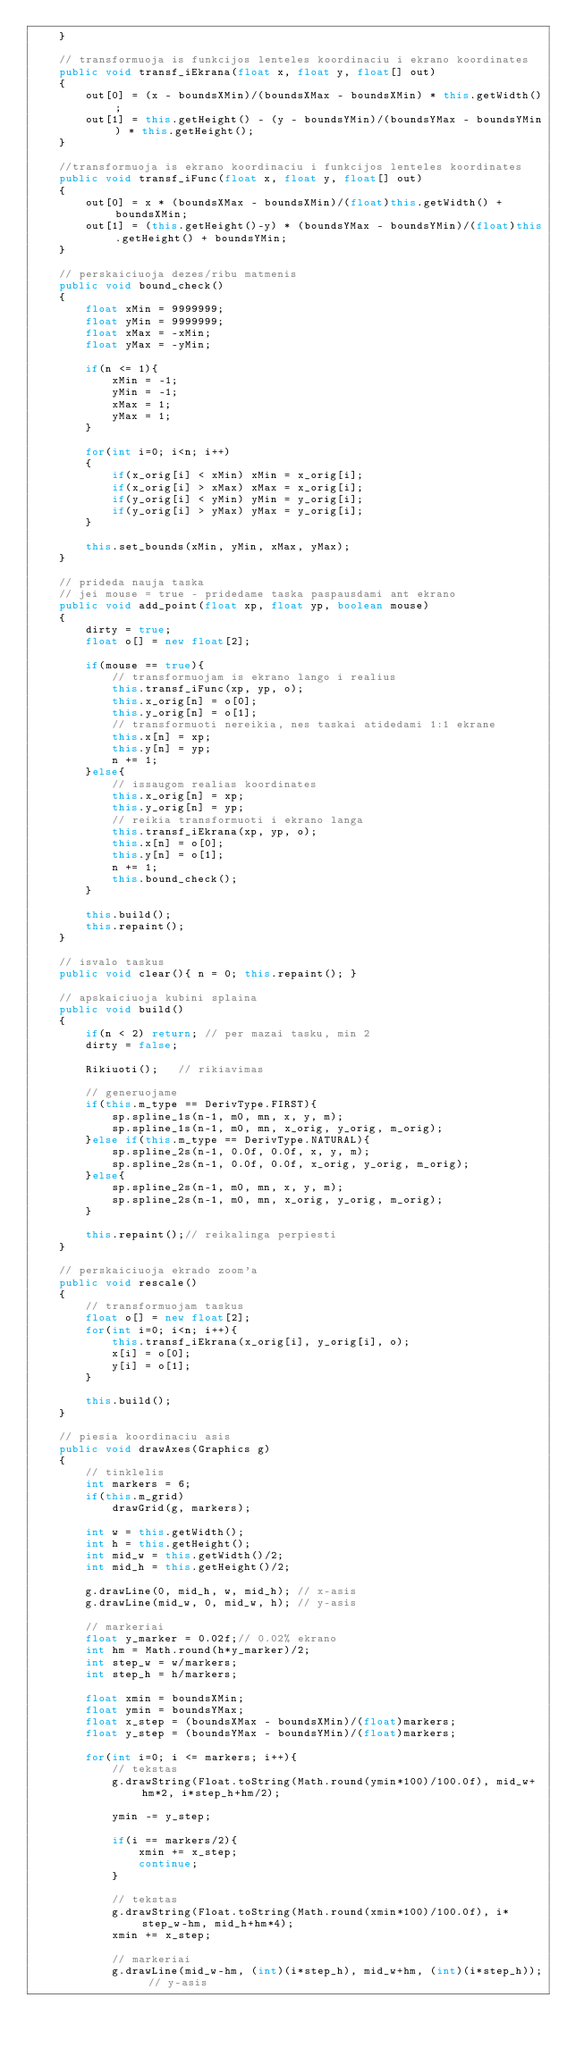Convert code to text. <code><loc_0><loc_0><loc_500><loc_500><_Java_>    }

    // transformuoja is funkcijos lenteles koordinaciu i ekrano koordinates
    public void transf_iEkrana(float x, float y, float[] out)
    {
        out[0] = (x - boundsXMin)/(boundsXMax - boundsXMin) * this.getWidth();
        out[1] = this.getHeight() - (y - boundsYMin)/(boundsYMax - boundsYMin) * this.getHeight();
    }

    //transformuoja is ekrano koordinaciu i funkcijos lenteles koordinates
    public void transf_iFunc(float x, float y, float[] out)
    {
        out[0] = x * (boundsXMax - boundsXMin)/(float)this.getWidth() + boundsXMin;
        out[1] = (this.getHeight()-y) * (boundsYMax - boundsYMin)/(float)this.getHeight() + boundsYMin;
    }

    // perskaiciuoja dezes/ribu matmenis
    public void bound_check()
    {
        float xMin = 9999999;
        float yMin = 9999999;
        float xMax = -xMin;
        float yMax = -yMin;

        if(n <= 1){
            xMin = -1;
            yMin = -1;
            xMax = 1;
            yMax = 1;
        }

        for(int i=0; i<n; i++)
        {
            if(x_orig[i] < xMin) xMin = x_orig[i];
            if(x_orig[i] > xMax) xMax = x_orig[i];
            if(y_orig[i] < yMin) yMin = y_orig[i];
            if(y_orig[i] > yMax) yMax = y_orig[i];
        }

        this.set_bounds(xMin, yMin, xMax, yMax);
    }

    // prideda nauja taska
    // jei mouse = true - pridedame taska paspausdami ant ekrano
    public void add_point(float xp, float yp, boolean mouse)
    {
        dirty = true;
        float o[] = new float[2];

        if(mouse == true){
            // transformuojam is ekrano lango i realius
            this.transf_iFunc(xp, yp, o);
            this.x_orig[n] = o[0];
            this.y_orig[n] = o[1];
            // transformuoti nereikia, nes taskai atidedami 1:1 ekrane
            this.x[n] = xp;
            this.y[n] = yp;
            n += 1;
        }else{
            // issaugom realias koordinates
            this.x_orig[n] = xp;
            this.y_orig[n] = yp;
            // reikia transformuoti i ekrano langa
            this.transf_iEkrana(xp, yp, o);
            this.x[n] = o[0];
            this.y[n] = o[1];
            n += 1;
            this.bound_check();
        }

        this.build();
        this.repaint();
    }

    // isvalo taskus
    public void clear(){ n = 0; this.repaint(); }

    // apskaiciuoja kubini splaina
    public void build()
    {
        if(n < 2) return; // per mazai tasku, min 2
        dirty = false;

        Rikiuoti();   // rikiavimas

        // generuojame
        if(this.m_type == DerivType.FIRST){
            sp.spline_1s(n-1, m0, mn, x, y, m);
            sp.spline_1s(n-1, m0, mn, x_orig, y_orig, m_orig);
        }else if(this.m_type == DerivType.NATURAL){
            sp.spline_2s(n-1, 0.0f, 0.0f, x, y, m);
            sp.spline_2s(n-1, 0.0f, 0.0f, x_orig, y_orig, m_orig);
        }else{
            sp.spline_2s(n-1, m0, mn, x, y, m);
            sp.spline_2s(n-1, m0, mn, x_orig, y_orig, m_orig);
        }
        
        this.repaint();// reikalinga perpiesti
    }

    // perskaiciuoja ekrado zoom'a
    public void rescale()
    {
        // transformuojam taskus
        float o[] = new float[2];
        for(int i=0; i<n; i++){
            this.transf_iEkrana(x_orig[i], y_orig[i], o);
            x[i] = o[0];
            y[i] = o[1];
        }

        this.build();
    }

    // piesia koordinaciu asis
    public void drawAxes(Graphics g)
    {
        // tinklelis
        int markers = 6;
        if(this.m_grid)
            drawGrid(g, markers);

        int w = this.getWidth();
        int h = this.getHeight();
        int mid_w = this.getWidth()/2;
        int mid_h = this.getHeight()/2;

        g.drawLine(0, mid_h, w, mid_h); // x-asis
        g.drawLine(mid_w, 0, mid_w, h); // y-asis

        // markeriai
        float y_marker = 0.02f;// 0.02% ekrano
        int hm = Math.round(h*y_marker)/2;
        int step_w = w/markers;
        int step_h = h/markers;

        float xmin = boundsXMin;
        float ymin = boundsYMax;
        float x_step = (boundsXMax - boundsXMin)/(float)markers;
        float y_step = (boundsYMax - boundsYMin)/(float)markers;
        
        for(int i=0; i <= markers; i++){
            // tekstas
            g.drawString(Float.toString(Math.round(ymin*100)/100.0f), mid_w+hm*2, i*step_h+hm/2);

            ymin -= y_step;
            
            if(i == markers/2){
                xmin += x_step;
                continue;
            }
            
            // tekstas
            g.drawString(Float.toString(Math.round(xmin*100)/100.0f), i*step_w-hm, mid_h+hm*4);
            xmin += x_step;

            // markeriai
            g.drawLine(mid_w-hm, (int)(i*step_h), mid_w+hm, (int)(i*step_h)); // y-asis</code> 